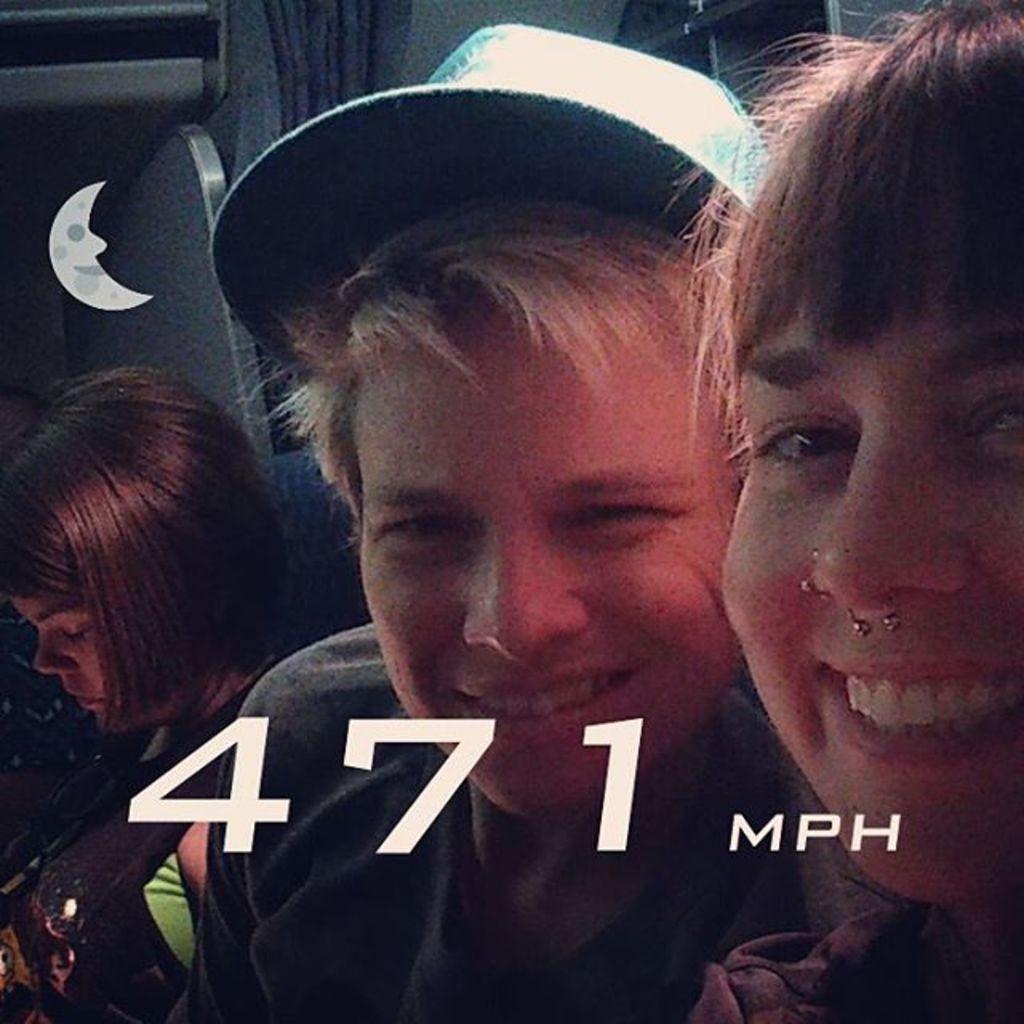Could you give a brief overview of what you see in this image? In this image we can see this woman is smiling, this person is wearing a cap on his head and in the background, we can see another woman and curtains here. 